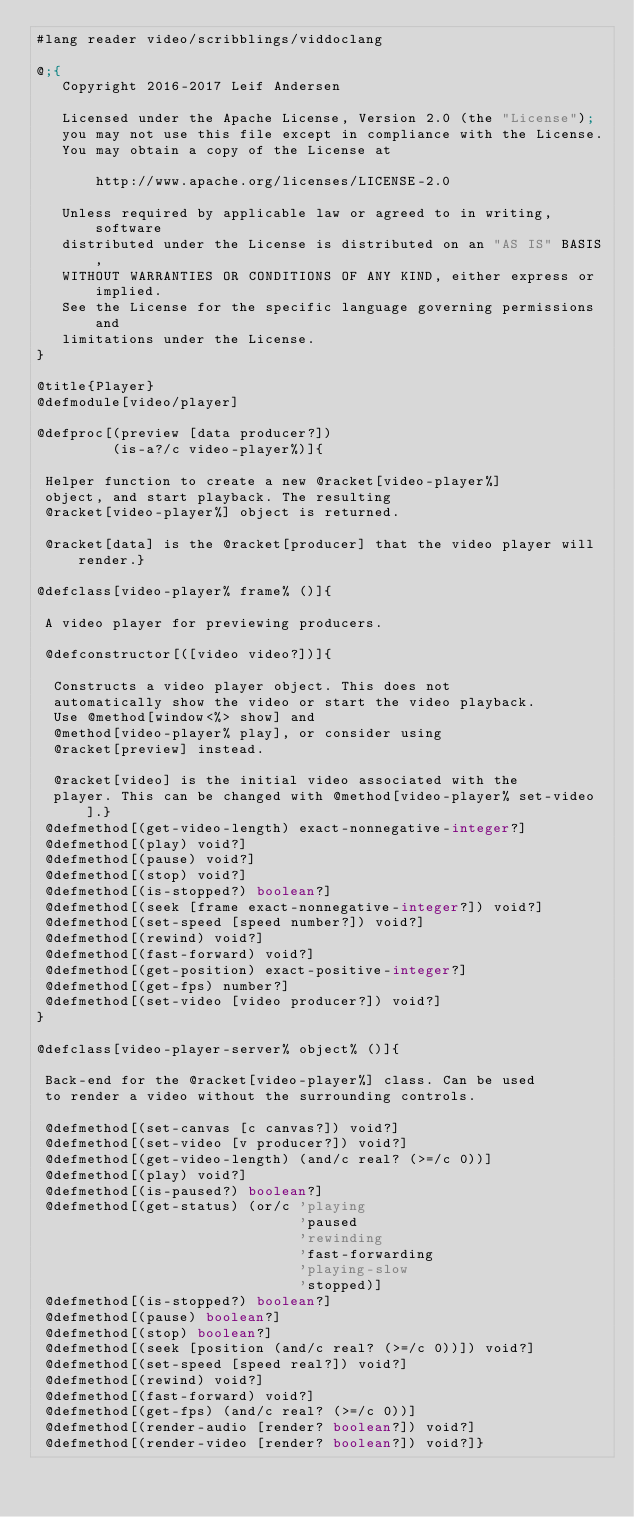Convert code to text. <code><loc_0><loc_0><loc_500><loc_500><_Racket_>#lang reader video/scribblings/viddoclang

@;{
   Copyright 2016-2017 Leif Andersen

   Licensed under the Apache License, Version 2.0 (the "License");
   you may not use this file except in compliance with the License.
   You may obtain a copy of the License at

       http://www.apache.org/licenses/LICENSE-2.0

   Unless required by applicable law or agreed to in writing, software
   distributed under the License is distributed on an "AS IS" BASIS,
   WITHOUT WARRANTIES OR CONDITIONS OF ANY KIND, either express or implied.
   See the License for the specific language governing permissions and
   limitations under the License.
}

@title{Player}
@defmodule[video/player]

@defproc[(preview [data producer?])
         (is-a?/c video-player%)]{
                                  
 Helper function to create a new @racket[video-player%]
 object, and start playback. The resulting
 @racket[video-player%] object is returned.
 
 @racket[data] is the @racket[producer] that the video player will render.}

@defclass[video-player% frame% ()]{
                                   
 A video player for previewing producers.
 
 @defconstructor[([video video?])]{
                                   
  Constructs a video player object. This does not
  automatically show the video or start the video playback.
  Use @method[window<%> show] and
  @method[video-player% play], or consider using
  @racket[preview] instead.

  @racket[video] is the initial video associated with the
  player. This can be changed with @method[video-player% set-video].}
 @defmethod[(get-video-length) exact-nonnegative-integer?]
 @defmethod[(play) void?]
 @defmethod[(pause) void?]
 @defmethod[(stop) void?]
 @defmethod[(is-stopped?) boolean?]
 @defmethod[(seek [frame exact-nonnegative-integer?]) void?]
 @defmethod[(set-speed [speed number?]) void?]
 @defmethod[(rewind) void?]
 @defmethod[(fast-forward) void?]
 @defmethod[(get-position) exact-positive-integer?]
 @defmethod[(get-fps) number?]
 @defmethod[(set-video [video producer?]) void?]
}

@defclass[video-player-server% object% ()]{
                                           
 Back-end for the @racket[video-player%] class. Can be used
 to render a video without the surrounding controls.
 
 @defmethod[(set-canvas [c canvas?]) void?]
 @defmethod[(set-video [v producer?]) void?]
 @defmethod[(get-video-length) (and/c real? (>=/c 0))]
 @defmethod[(play) void?]
 @defmethod[(is-paused?) boolean?]
 @defmethod[(get-status) (or/c 'playing
                               'paused
                               'rewinding
                               'fast-forwarding
                               'playing-slow
                               'stopped)]
 @defmethod[(is-stopped?) boolean?]
 @defmethod[(pause) boolean?]
 @defmethod[(stop) boolean?]
 @defmethod[(seek [position (and/c real? (>=/c 0))]) void?]
 @defmethod[(set-speed [speed real?]) void?]
 @defmethod[(rewind) void?]
 @defmethod[(fast-forward) void?]
 @defmethod[(get-fps) (and/c real? (>=/c 0))]
 @defmethod[(render-audio [render? boolean?]) void?]
 @defmethod[(render-video [render? boolean?]) void?]}
</code> 